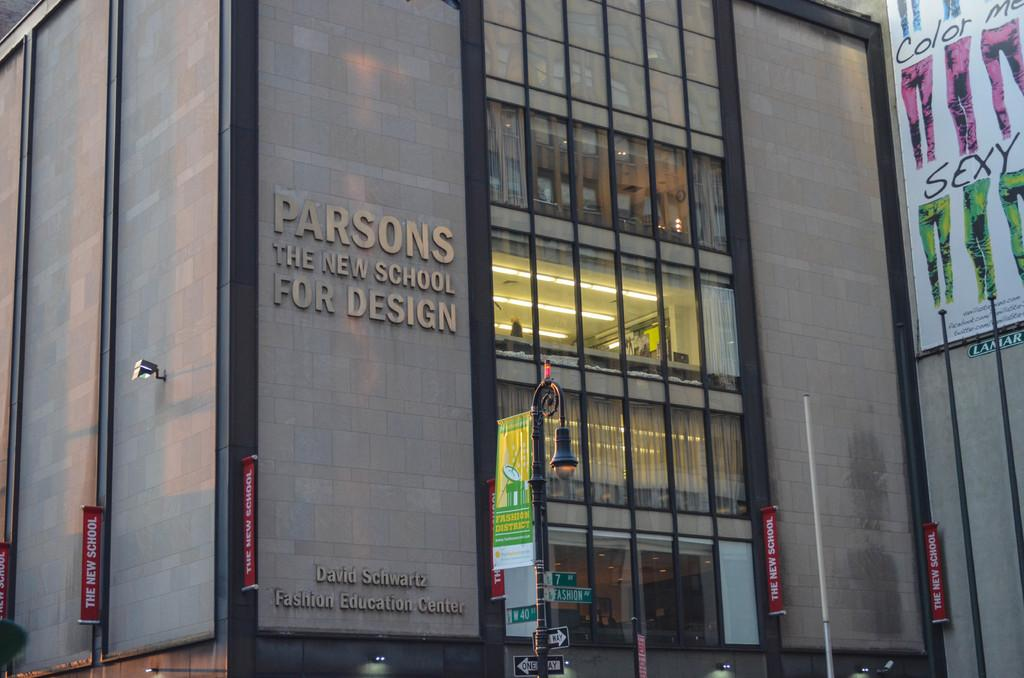What is the main object in the image? There is a street light in the image. What is unique about this street light? The street light has boards attached to the pole. What can be seen on the right side of the image? There are poles on the right side of the image. Where is a banner located in the image? There is a banner attached to the wall of a building in the top right corner of the image. What type of flight is taking off from the street light in the image? There is no flight present in the image; it features a street light with boards attached to the pole. What season is depicted in the image, considering the presence of spring flowers? There is no mention of spring flowers or any seasonal elements in the image; it only shows a street light, boards, poles, and a banner. 